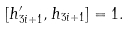<formula> <loc_0><loc_0><loc_500><loc_500>[ h ^ { \prime } _ { 3 i + 1 } , h _ { 3 i + 1 } ] = 1 .</formula> 